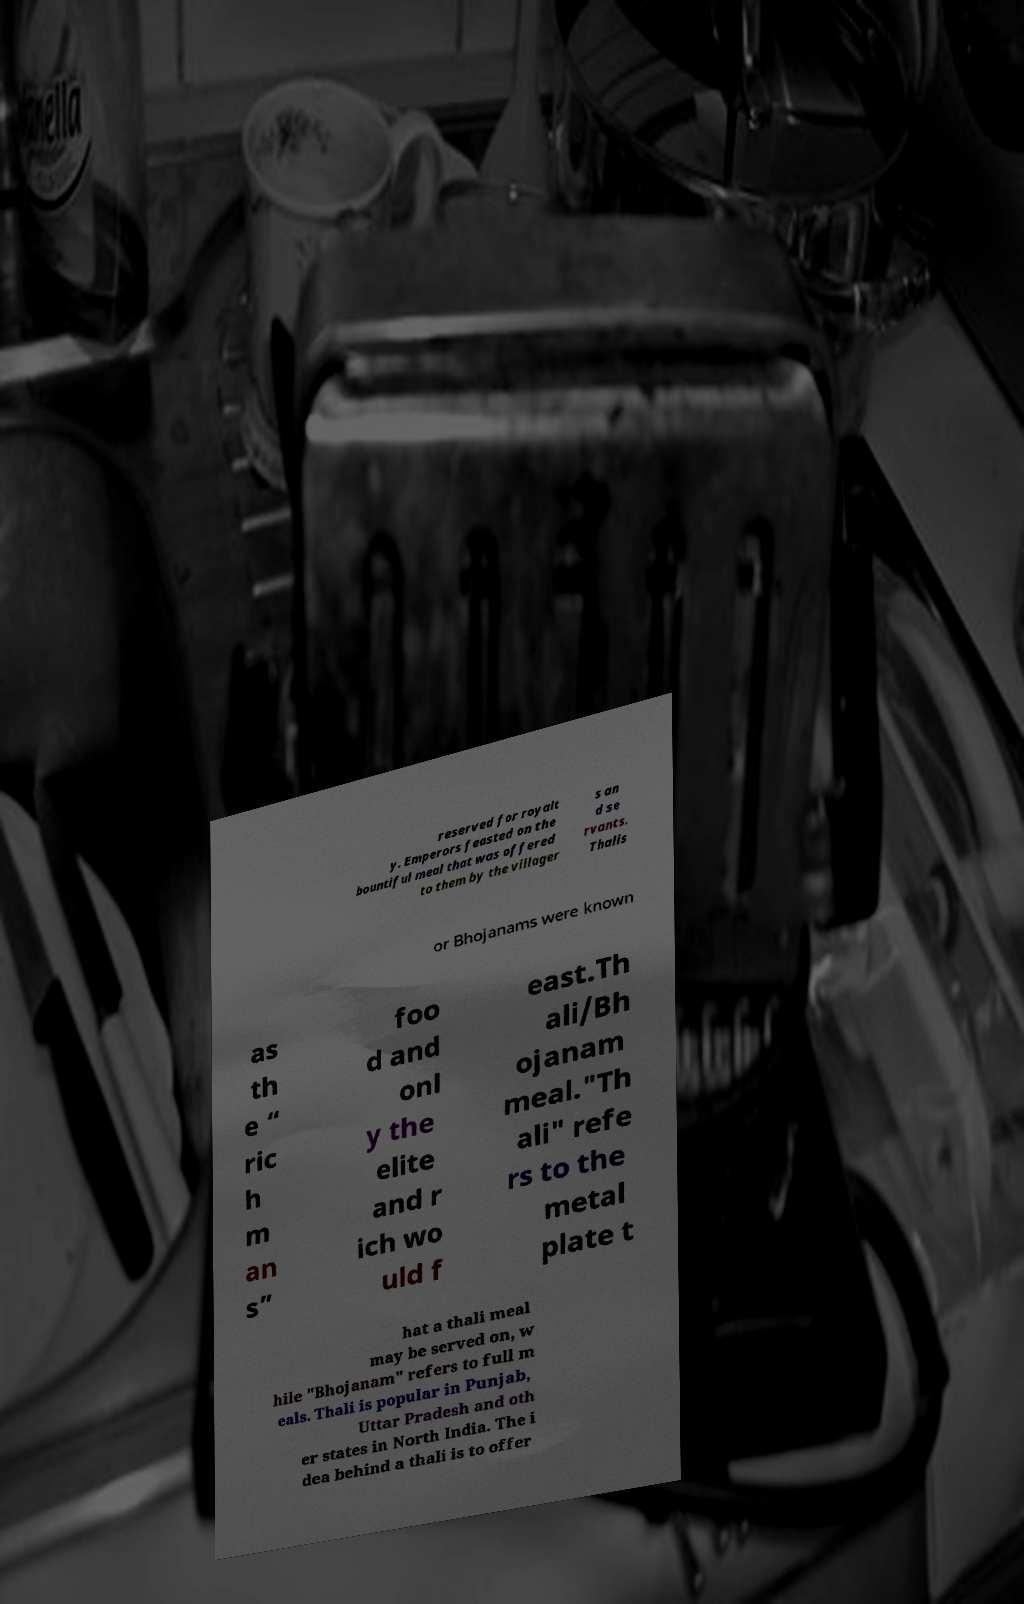Can you accurately transcribe the text from the provided image for me? reserved for royalt y. Emperors feasted on the bountiful meal that was offered to them by the villager s an d se rvants. Thalis or Bhojanams were known as th e “ ric h m an s” foo d and onl y the elite and r ich wo uld f east.Th ali/Bh ojanam meal."Th ali" refe rs to the metal plate t hat a thali meal may be served on, w hile "Bhojanam" refers to full m eals. Thali is popular in Punjab, Uttar Pradesh and oth er states in North India. The i dea behind a thali is to offer 